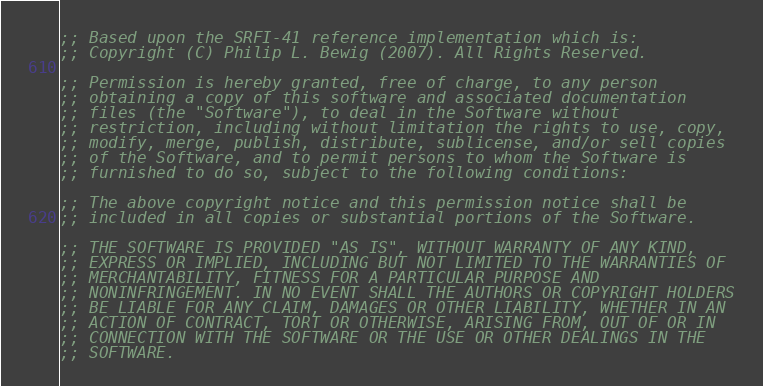<code> <loc_0><loc_0><loc_500><loc_500><_Scheme_>;; Based upon the SRFI-41 reference implementation which is:
;; Copyright (C) Philip L. Bewig (2007). All Rights Reserved.

;; Permission is hereby granted, free of charge, to any person
;; obtaining a copy of this software and associated documentation
;; files (the "Software"), to deal in the Software without
;; restriction, including without limitation the rights to use, copy,
;; modify, merge, publish, distribute, sublicense, and/or sell copies
;; of the Software, and to permit persons to whom the Software is
;; furnished to do so, subject to the following conditions:

;; The above copyright notice and this permission notice shall be
;; included in all copies or substantial portions of the Software.

;; THE SOFTWARE IS PROVIDED "AS IS", WITHOUT WARRANTY OF ANY KIND,
;; EXPRESS OR IMPLIED, INCLUDING BUT NOT LIMITED TO THE WARRANTIES OF
;; MERCHANTABILITY, FITNESS FOR A PARTICULAR PURPOSE AND
;; NONINFRINGEMENT. IN NO EVENT SHALL THE AUTHORS OR COPYRIGHT HOLDERS
;; BE LIABLE FOR ANY CLAIM, DAMAGES OR OTHER LIABILITY, WHETHER IN AN
;; ACTION OF CONTRACT, TORT OR OTHERWISE, ARISING FROM, OUT OF OR IN
;; CONNECTION WITH THE SOFTWARE OR THE USE OR OTHER DEALINGS IN THE
;; SOFTWARE.
</code> 